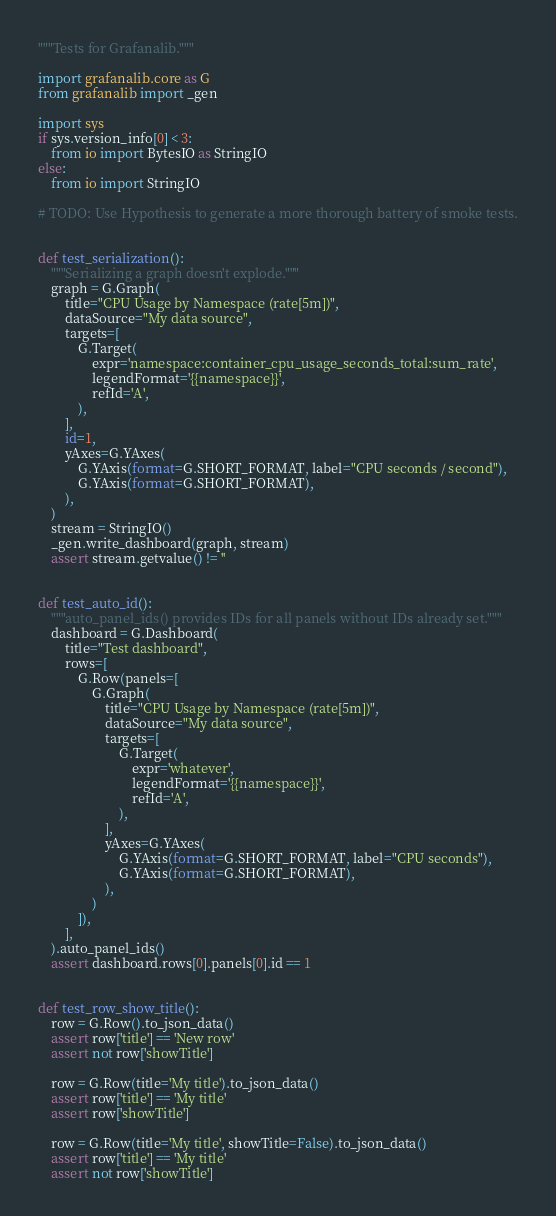<code> <loc_0><loc_0><loc_500><loc_500><_Python_>"""Tests for Grafanalib."""

import grafanalib.core as G
from grafanalib import _gen

import sys
if sys.version_info[0] < 3:
    from io import BytesIO as StringIO
else:
    from io import StringIO

# TODO: Use Hypothesis to generate a more thorough battery of smoke tests.


def test_serialization():
    """Serializing a graph doesn't explode."""
    graph = G.Graph(
        title="CPU Usage by Namespace (rate[5m])",
        dataSource="My data source",
        targets=[
            G.Target(
                expr='namespace:container_cpu_usage_seconds_total:sum_rate',
                legendFormat='{{namespace}}',
                refId='A',
            ),
        ],
        id=1,
        yAxes=G.YAxes(
            G.YAxis(format=G.SHORT_FORMAT, label="CPU seconds / second"),
            G.YAxis(format=G.SHORT_FORMAT),
        ),
    )
    stream = StringIO()
    _gen.write_dashboard(graph, stream)
    assert stream.getvalue() != ''


def test_auto_id():
    """auto_panel_ids() provides IDs for all panels without IDs already set."""
    dashboard = G.Dashboard(
        title="Test dashboard",
        rows=[
            G.Row(panels=[
                G.Graph(
                    title="CPU Usage by Namespace (rate[5m])",
                    dataSource="My data source",
                    targets=[
                        G.Target(
                            expr='whatever',
                            legendFormat='{{namespace}}',
                            refId='A',
                        ),
                    ],
                    yAxes=G.YAxes(
                        G.YAxis(format=G.SHORT_FORMAT, label="CPU seconds"),
                        G.YAxis(format=G.SHORT_FORMAT),
                    ),
                )
            ]),
        ],
    ).auto_panel_ids()
    assert dashboard.rows[0].panels[0].id == 1


def test_row_show_title():
    row = G.Row().to_json_data()
    assert row['title'] == 'New row'
    assert not row['showTitle']

    row = G.Row(title='My title').to_json_data()
    assert row['title'] == 'My title'
    assert row['showTitle']

    row = G.Row(title='My title', showTitle=False).to_json_data()
    assert row['title'] == 'My title'
    assert not row['showTitle']
</code> 